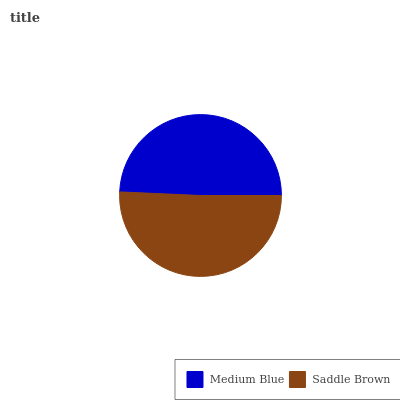Is Medium Blue the minimum?
Answer yes or no. Yes. Is Saddle Brown the maximum?
Answer yes or no. Yes. Is Saddle Brown the minimum?
Answer yes or no. No. Is Saddle Brown greater than Medium Blue?
Answer yes or no. Yes. Is Medium Blue less than Saddle Brown?
Answer yes or no. Yes. Is Medium Blue greater than Saddle Brown?
Answer yes or no. No. Is Saddle Brown less than Medium Blue?
Answer yes or no. No. Is Saddle Brown the high median?
Answer yes or no. Yes. Is Medium Blue the low median?
Answer yes or no. Yes. Is Medium Blue the high median?
Answer yes or no. No. Is Saddle Brown the low median?
Answer yes or no. No. 